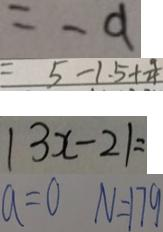<formula> <loc_0><loc_0><loc_500><loc_500>= - 9 
 = 5 - 1 . 5 + \frac { 9 } { 4 } 
 \vert 3 x - 2 \vert = 
 a = 0 N = 1 7 9</formula> 